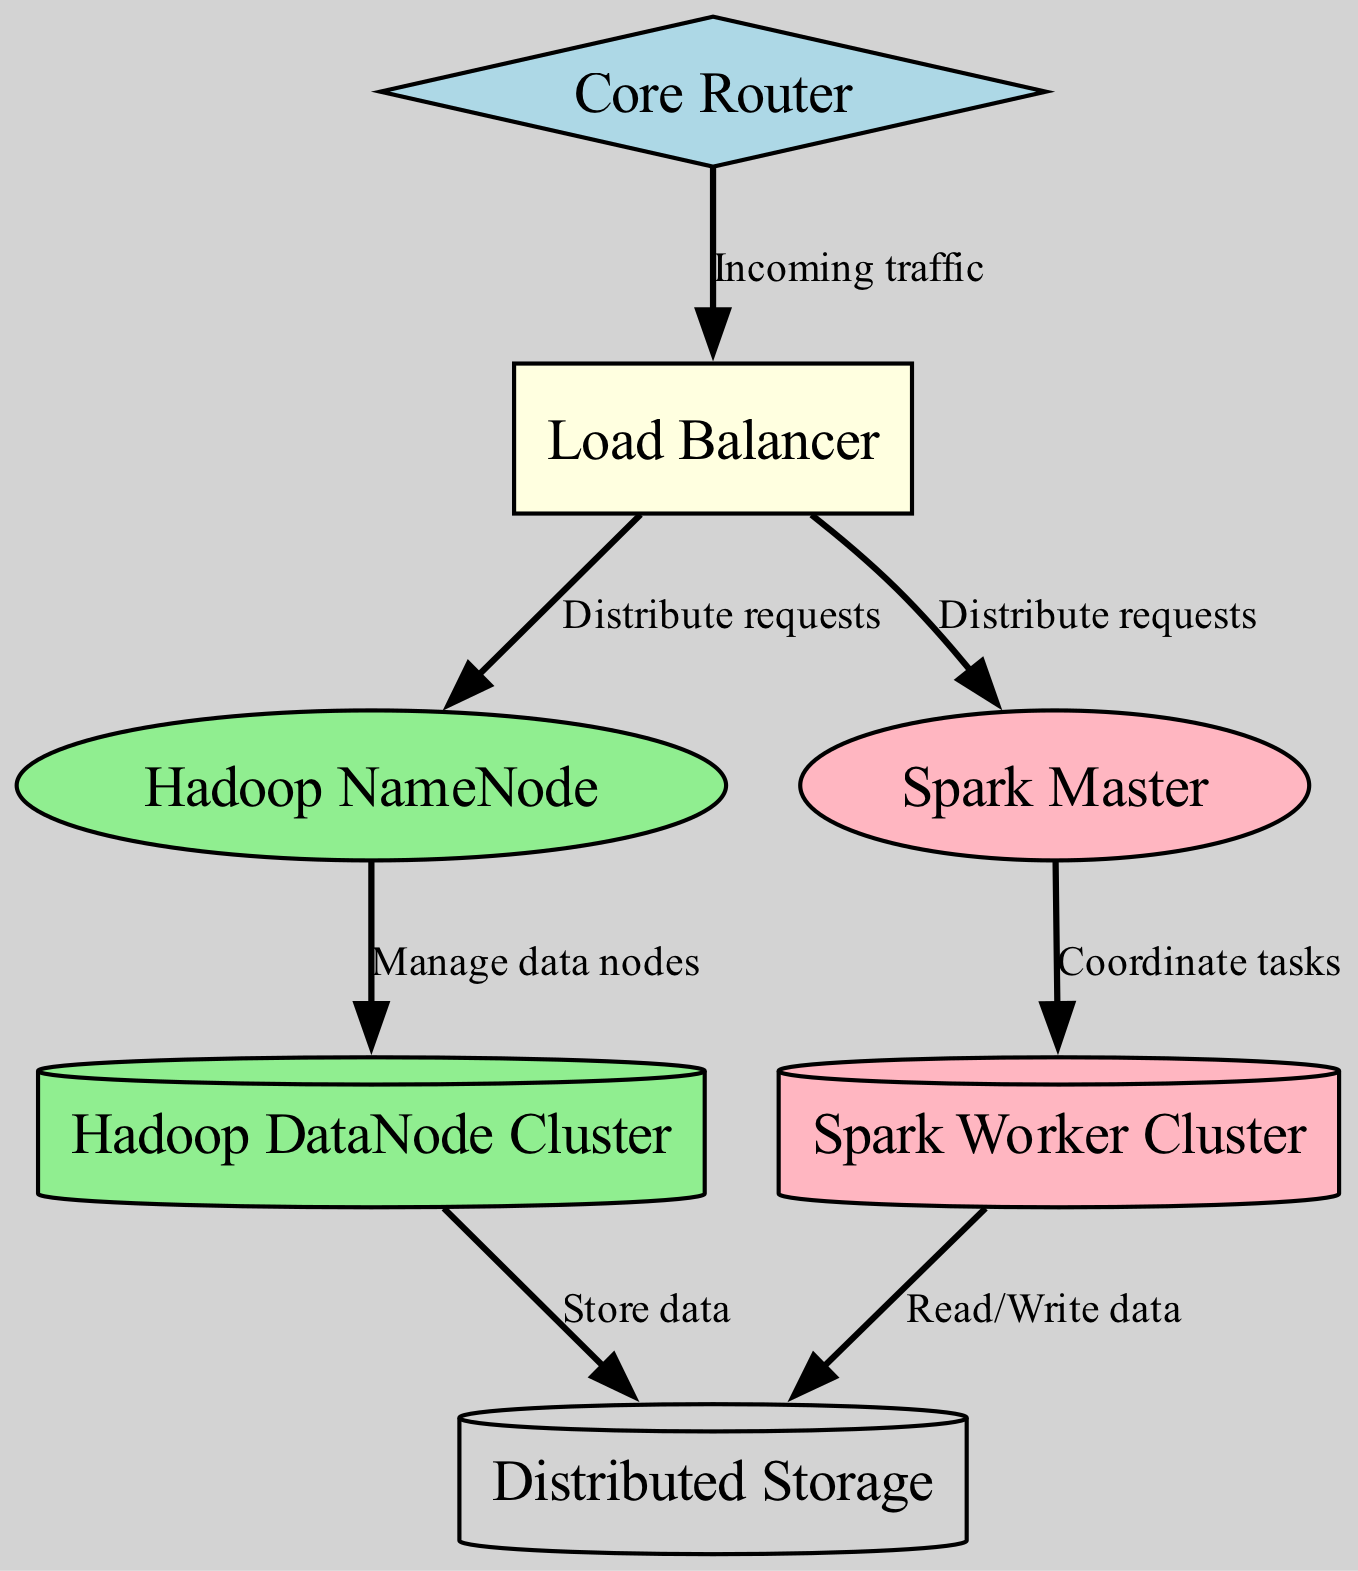What is the central node of the network topology? The diagram shows the Core Router as the starting point for incoming traffic, distributing requests to the Load Balancer. This indicates that the Core Router is the central node managing incoming connections.
Answer: Core Router How many nodes are present in the diagram? By counting the unique nodes listed, we identify that there are a total of seven nodes in the diagram.
Answer: Seven What is the relationship between the Load Balancer and the Hadoop NameNode? The Load Balancer distributes requests to the Hadoop NameNode, which is represented by a directed edge from the Load Balancer to the Hadoop NameNode in the diagram.
Answer: Distribute requests Which node manages the data nodes? The edge from the Hadoop NameNode to the Hadoop DataNode Cluster indicates that the Hadoop NameNode is responsible for managing data nodes in the network topology.
Answer: Hadoop NameNode How many edges connect the Load Balancer? The Load Balancer has two directed edges leading to different nodes (Hadoop NameNode and Spark Master). Therefore, it connects to two other nodes through edges.
Answer: Two What is the purpose of the connection from the Hadoop DataNode Cluster to the Distributed Storage? The edge indicates that the Hadoop DataNode Cluster stores data in the Distributed Storage, highlighting its role in data management.
Answer: Store data Which nodes are involved in data reading and writing processes? Examining the diagram, the connection from the Spark Worker Cluster to the Distributed Storage indicates that both nodes are involved in reading and writing data.
Answer: Spark Worker Cluster and Distributed Storage What is the type of the Core Router? The diagram categorizes the Core Router as a diamond shape with a light blue fill, indicating its specific type within the network topology.
Answer: Diamond What kind of tasks does the Spark Master coordinate? The edge from the Spark Master to the Spark Worker Cluster suggests that the Spark Master is responsible for coordinating tasks between workers, emphasizing its role in managing computational workflows.
Answer: Coordinate tasks 